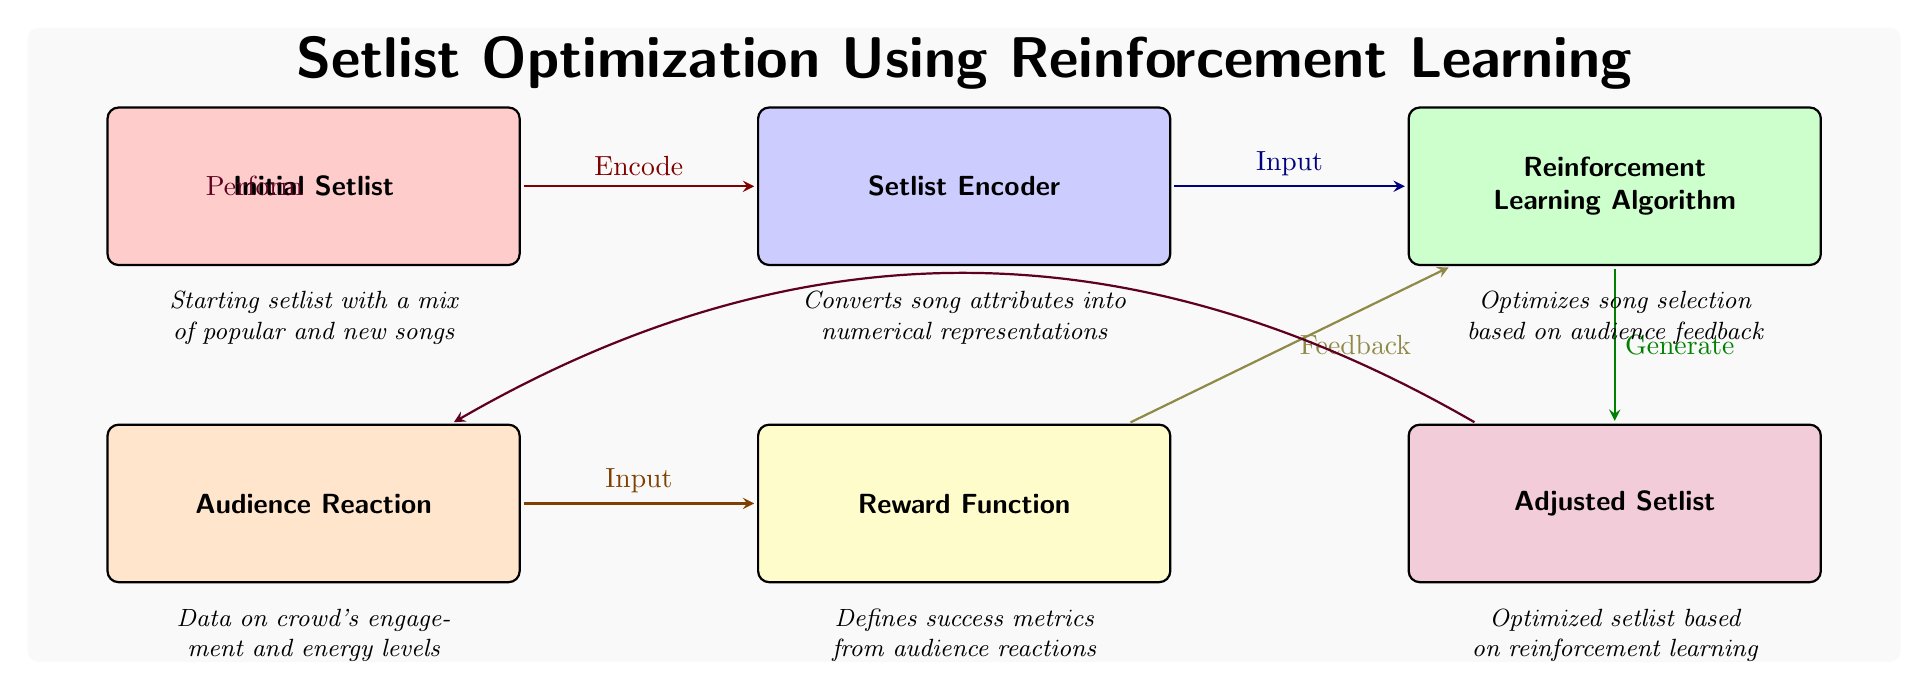What is the input to the reinforcement learning algorithm? The input to the reinforcement learning algorithm is provided by the setlist encoder, which receives the encoded representation of the initial setlist.
Answer: Setlist Encoder What flows from the adjusted setlist to the audience reaction? The adjusted setlist leads to the audience reaction through the performance of the optimized setlist, indicating the direct relationship of execution and engagement.
Answer: Perform How many nodes are present in the diagram? The diagram consists of six distinct nodes representing different components of the setlist optimization process.
Answer: Six What function does the reward function perform? The reward function takes in the audience reaction data and derives success metrics that serve as feedback for optimizing the setlist.
Answer: Defines success metrics Which node is responsible for generating the adjusted setlist? The generation of the adjusted setlist is done by the reinforcement learning algorithm, which utilizes input from audience reactions and the encoded setlist.
Answer: Reinforcement Learning Algorithm What color represents the initial setlist in the diagram? The color representing the initial setlist in the diagram is red, highlighting its role as the starting point of the optimization process.
Answer: Red What type of feedback does the reward function provide? The feedback provided by the reward function consists of success metrics derived from the audience's reactions during performances.
Answer: Feedback Which node is directly below the reinforcement learning algorithm? The node that is directly below the reinforcement learning algorithm is the adjusted setlist, demonstrating the output of the algorithmic process.
Answer: Adjusted Setlist 